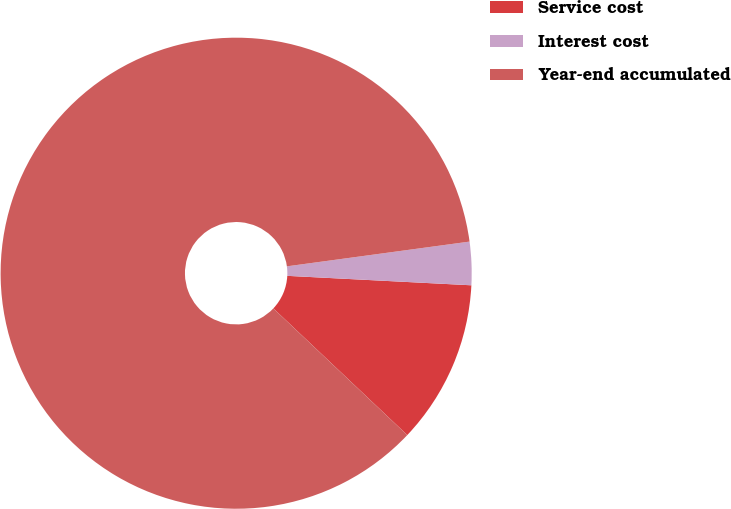Convert chart. <chart><loc_0><loc_0><loc_500><loc_500><pie_chart><fcel>Service cost<fcel>Interest cost<fcel>Year-end accumulated<nl><fcel>11.24%<fcel>2.96%<fcel>85.8%<nl></chart> 